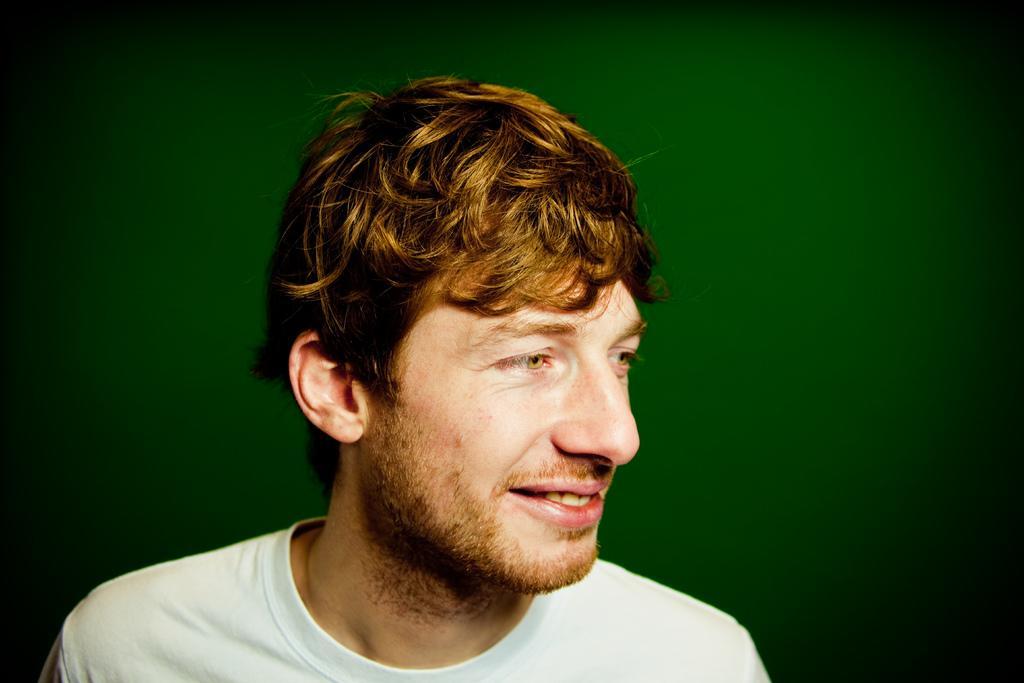Describe this image in one or two sentences. In the image there is a man in the foreground, he is laughing. 